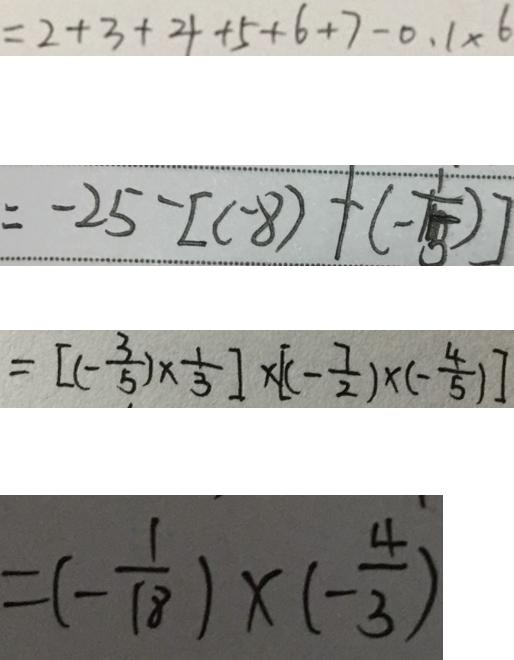Convert formula to latex. <formula><loc_0><loc_0><loc_500><loc_500>= 2 + 3 + 4 + 5 + 6 + 7 - 0 . 1 \times 6 
 = - 2 5 - [ ( - 8 ) + ( - \frac { 1 } { 1 5 } ) ] 
 = [ ( - \frac { 3 } { 5 } ) \times \frac { 1 } { 3 } ] \times [ ( - \frac { 7 } { 2 } ) \times ( - \frac { 4 } { 5 } ) ] 
 = ( - \frac { 1 } { 1 8 } ) \times ( - \frac { 4 } { 3 } )</formula> 